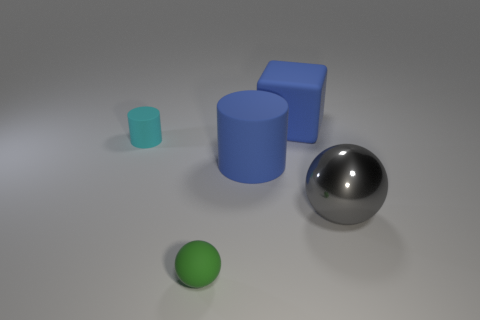The other object that is the same size as the cyan matte object is what shape?
Provide a succinct answer. Sphere. What number of things are large green rubber spheres or spheres that are to the left of the big matte cube?
Make the answer very short. 1. There is a cylinder left of the tiny rubber thing that is on the right side of the small cylinder; what number of blue matte things are behind it?
Keep it short and to the point. 1. What is the color of the tiny cylinder that is the same material as the large block?
Ensure brevity in your answer.  Cyan. There is a thing that is in front of the gray object; is its size the same as the blue block?
Ensure brevity in your answer.  No. How many things are blocks or red blocks?
Provide a succinct answer. 1. There is a object in front of the ball on the right side of the ball left of the gray shiny ball; what is it made of?
Keep it short and to the point. Rubber. There is a small thing to the left of the green ball; what is it made of?
Provide a succinct answer. Rubber. Is there a blue rubber object that has the same size as the blue matte cube?
Make the answer very short. Yes. Is the color of the ball on the right side of the small green rubber sphere the same as the tiny sphere?
Provide a succinct answer. No. 